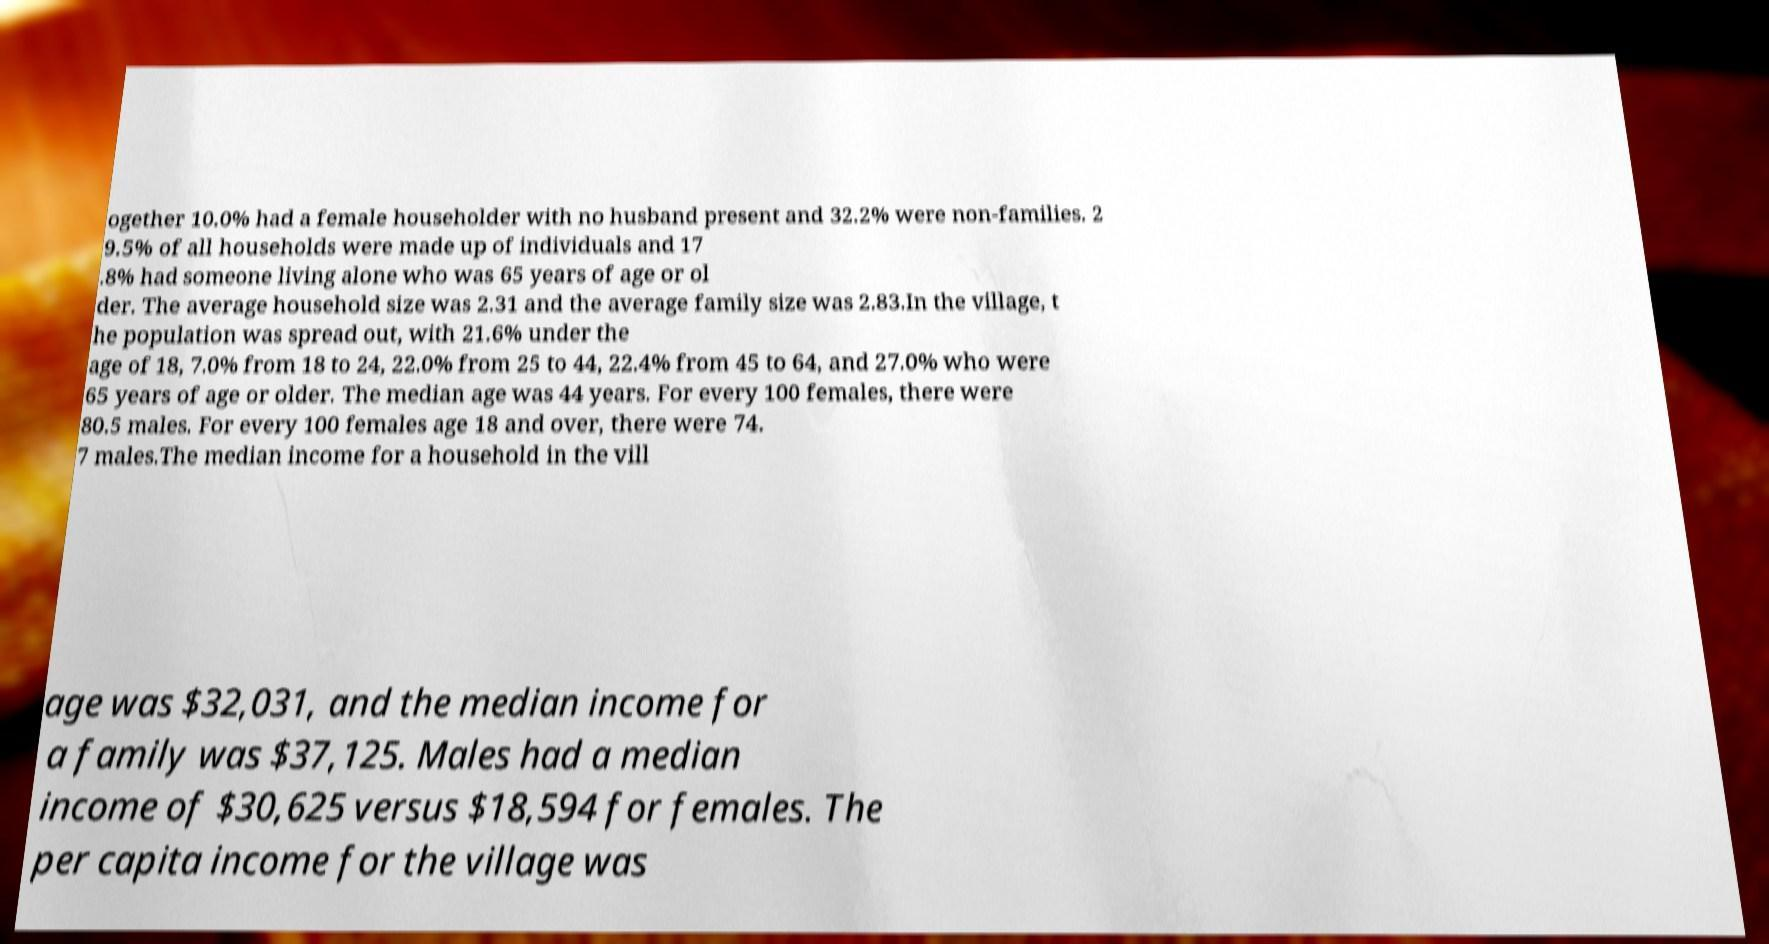Please read and relay the text visible in this image. What does it say? ogether 10.0% had a female householder with no husband present and 32.2% were non-families. 2 9.5% of all households were made up of individuals and 17 .8% had someone living alone who was 65 years of age or ol der. The average household size was 2.31 and the average family size was 2.83.In the village, t he population was spread out, with 21.6% under the age of 18, 7.0% from 18 to 24, 22.0% from 25 to 44, 22.4% from 45 to 64, and 27.0% who were 65 years of age or older. The median age was 44 years. For every 100 females, there were 80.5 males. For every 100 females age 18 and over, there were 74. 7 males.The median income for a household in the vill age was $32,031, and the median income for a family was $37,125. Males had a median income of $30,625 versus $18,594 for females. The per capita income for the village was 